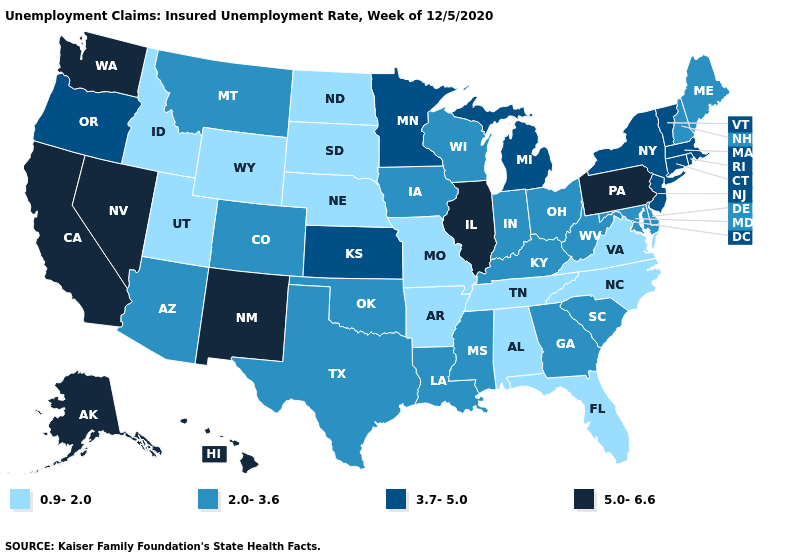Does Delaware have the lowest value in the USA?
Answer briefly. No. Does Washington have the highest value in the West?
Give a very brief answer. Yes. Which states have the lowest value in the Northeast?
Concise answer only. Maine, New Hampshire. What is the highest value in the USA?
Be succinct. 5.0-6.6. Does Indiana have the lowest value in the USA?
Quick response, please. No. Name the states that have a value in the range 5.0-6.6?
Be succinct. Alaska, California, Hawaii, Illinois, Nevada, New Mexico, Pennsylvania, Washington. What is the value of Delaware?
Concise answer only. 2.0-3.6. Among the states that border Montana , which have the highest value?
Concise answer only. Idaho, North Dakota, South Dakota, Wyoming. Among the states that border Pennsylvania , does New York have the lowest value?
Short answer required. No. Name the states that have a value in the range 0.9-2.0?
Be succinct. Alabama, Arkansas, Florida, Idaho, Missouri, Nebraska, North Carolina, North Dakota, South Dakota, Tennessee, Utah, Virginia, Wyoming. Name the states that have a value in the range 3.7-5.0?
Give a very brief answer. Connecticut, Kansas, Massachusetts, Michigan, Minnesota, New Jersey, New York, Oregon, Rhode Island, Vermont. What is the highest value in the USA?
Be succinct. 5.0-6.6. What is the highest value in the MidWest ?
Be succinct. 5.0-6.6. Is the legend a continuous bar?
Answer briefly. No. What is the lowest value in the West?
Give a very brief answer. 0.9-2.0. 